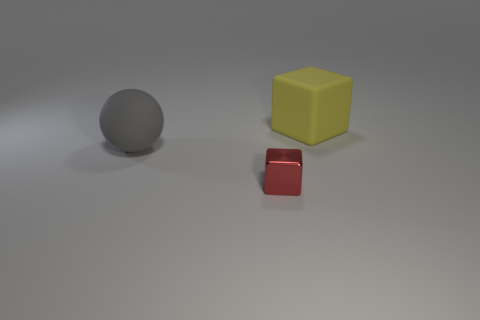Are there any other things that are the same material as the small object?
Offer a terse response. No. What material is the small red object that is the same shape as the yellow thing?
Give a very brief answer. Metal. Are there fewer big gray things left of the ball than tiny brown shiny things?
Ensure brevity in your answer.  No. How many things are to the left of the small object?
Provide a succinct answer. 1. There is a thing in front of the big gray ball; is its shape the same as the object right of the small metallic thing?
Give a very brief answer. Yes. There is a object that is behind the tiny red metallic cube and to the right of the gray matte sphere; what shape is it?
Your response must be concise. Cube. Are there fewer gray rubber cylinders than yellow things?
Provide a short and direct response. Yes. There is a large object that is behind the matte thing to the left of the block behind the large gray sphere; what is it made of?
Keep it short and to the point. Rubber. Does the big object that is in front of the yellow matte cube have the same material as the cube to the left of the yellow matte thing?
Provide a succinct answer. No. What is the size of the thing that is to the right of the gray rubber ball and to the left of the yellow matte block?
Provide a short and direct response. Small. 